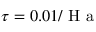Convert formula to latex. <formula><loc_0><loc_0><loc_500><loc_500>\tau = 0 . 0 1 / H a</formula> 